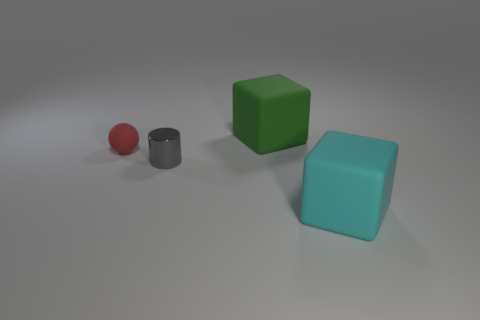There is a large object that is left of the block in front of the gray thing; how many big green cubes are behind it?
Your response must be concise. 0. There is a big thing that is behind the tiny object in front of the small red sphere; what is its shape?
Provide a short and direct response. Cube. What size is the other thing that is the same shape as the green rubber object?
Keep it short and to the point. Large. What color is the object to the left of the tiny metallic thing?
Your response must be concise. Red. What is the large block that is right of the big matte cube to the left of the thing that is on the right side of the big green matte thing made of?
Your answer should be very brief. Rubber. How big is the rubber cube that is behind the matte cube that is in front of the red sphere?
Your response must be concise. Large. The other matte object that is the same shape as the big green matte thing is what color?
Your answer should be very brief. Cyan. What number of rubber things are the same color as the tiny ball?
Give a very brief answer. 0. Do the ball and the cyan matte thing have the same size?
Your answer should be compact. No. What is the material of the small sphere?
Keep it short and to the point. Rubber. 